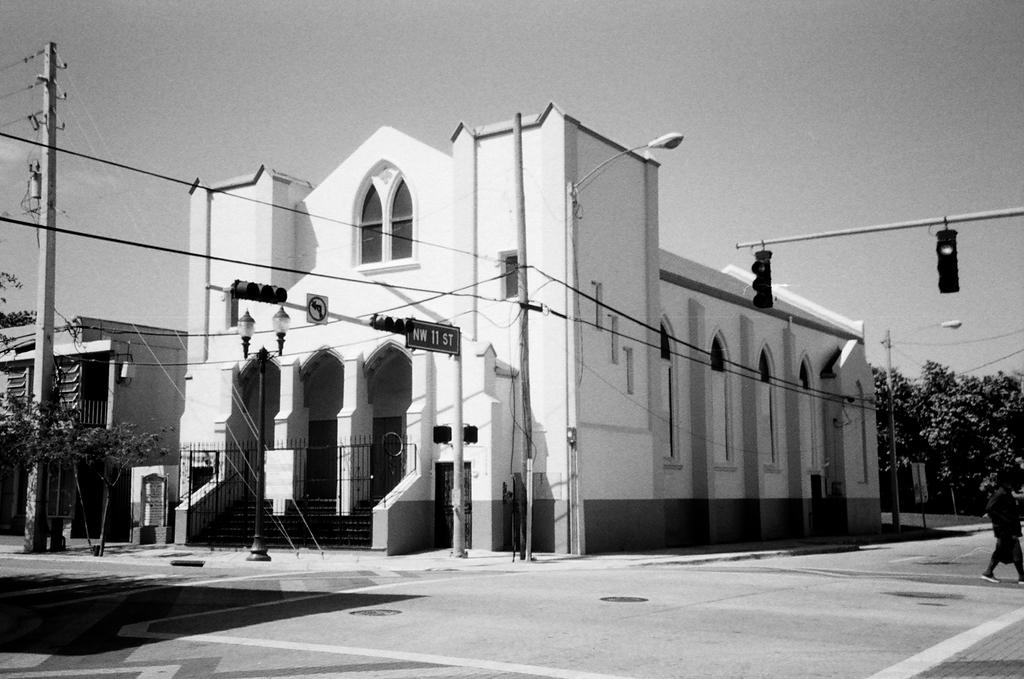What is the color scheme of the image? The image is black and white. Can you describe the person in the image? There is a person at the right side of the image. What type of traffic control device is present in the image? There are traffic lights in the image. What other objects can be seen in the image? There are poles and wires in the image. What can be seen in the background of the image? There are buildings in the background of the image. How can the person in the image join the quiet drug party happening in the background? There is no indication of a drug party or any quiet gathering in the background of the image. 